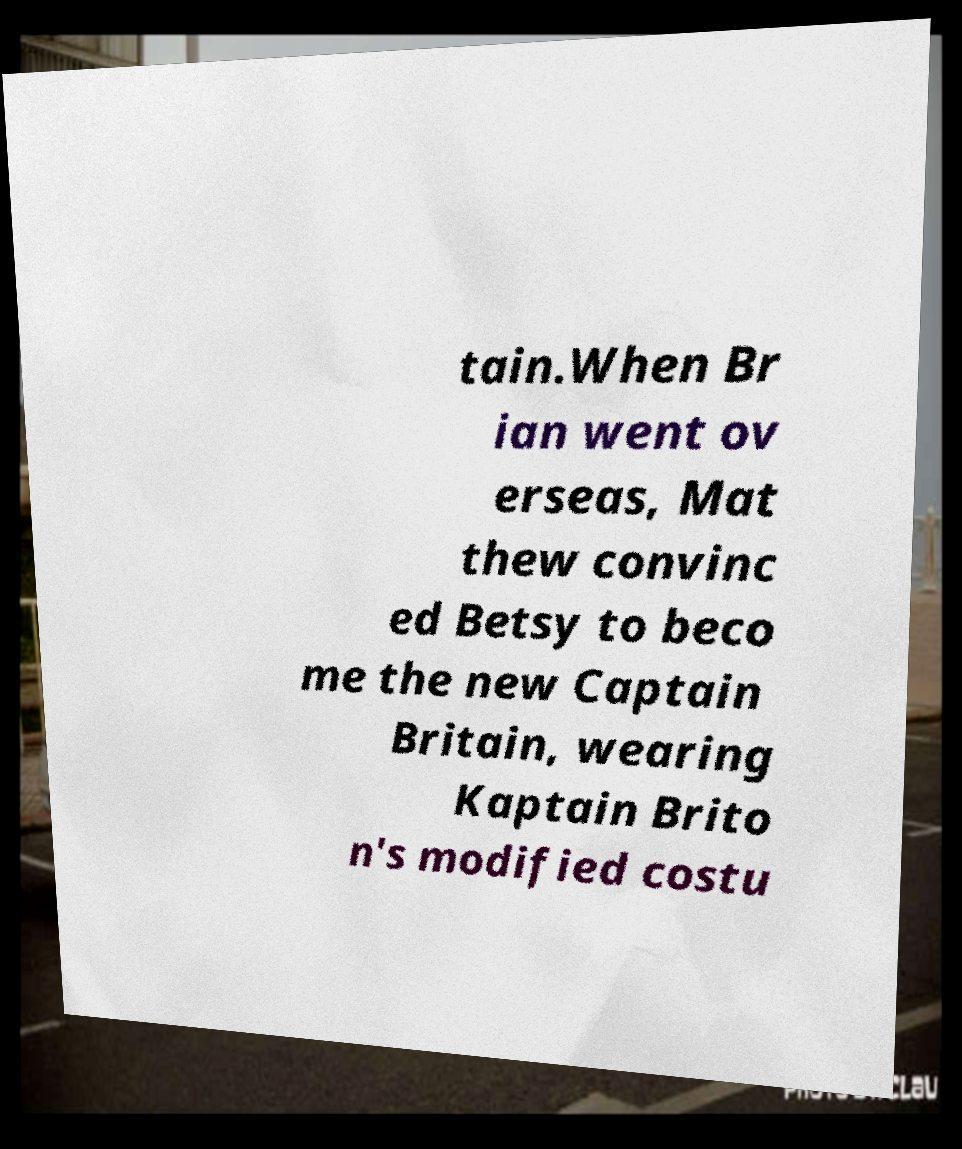For documentation purposes, I need the text within this image transcribed. Could you provide that? tain.When Br ian went ov erseas, Mat thew convinc ed Betsy to beco me the new Captain Britain, wearing Kaptain Brito n's modified costu 